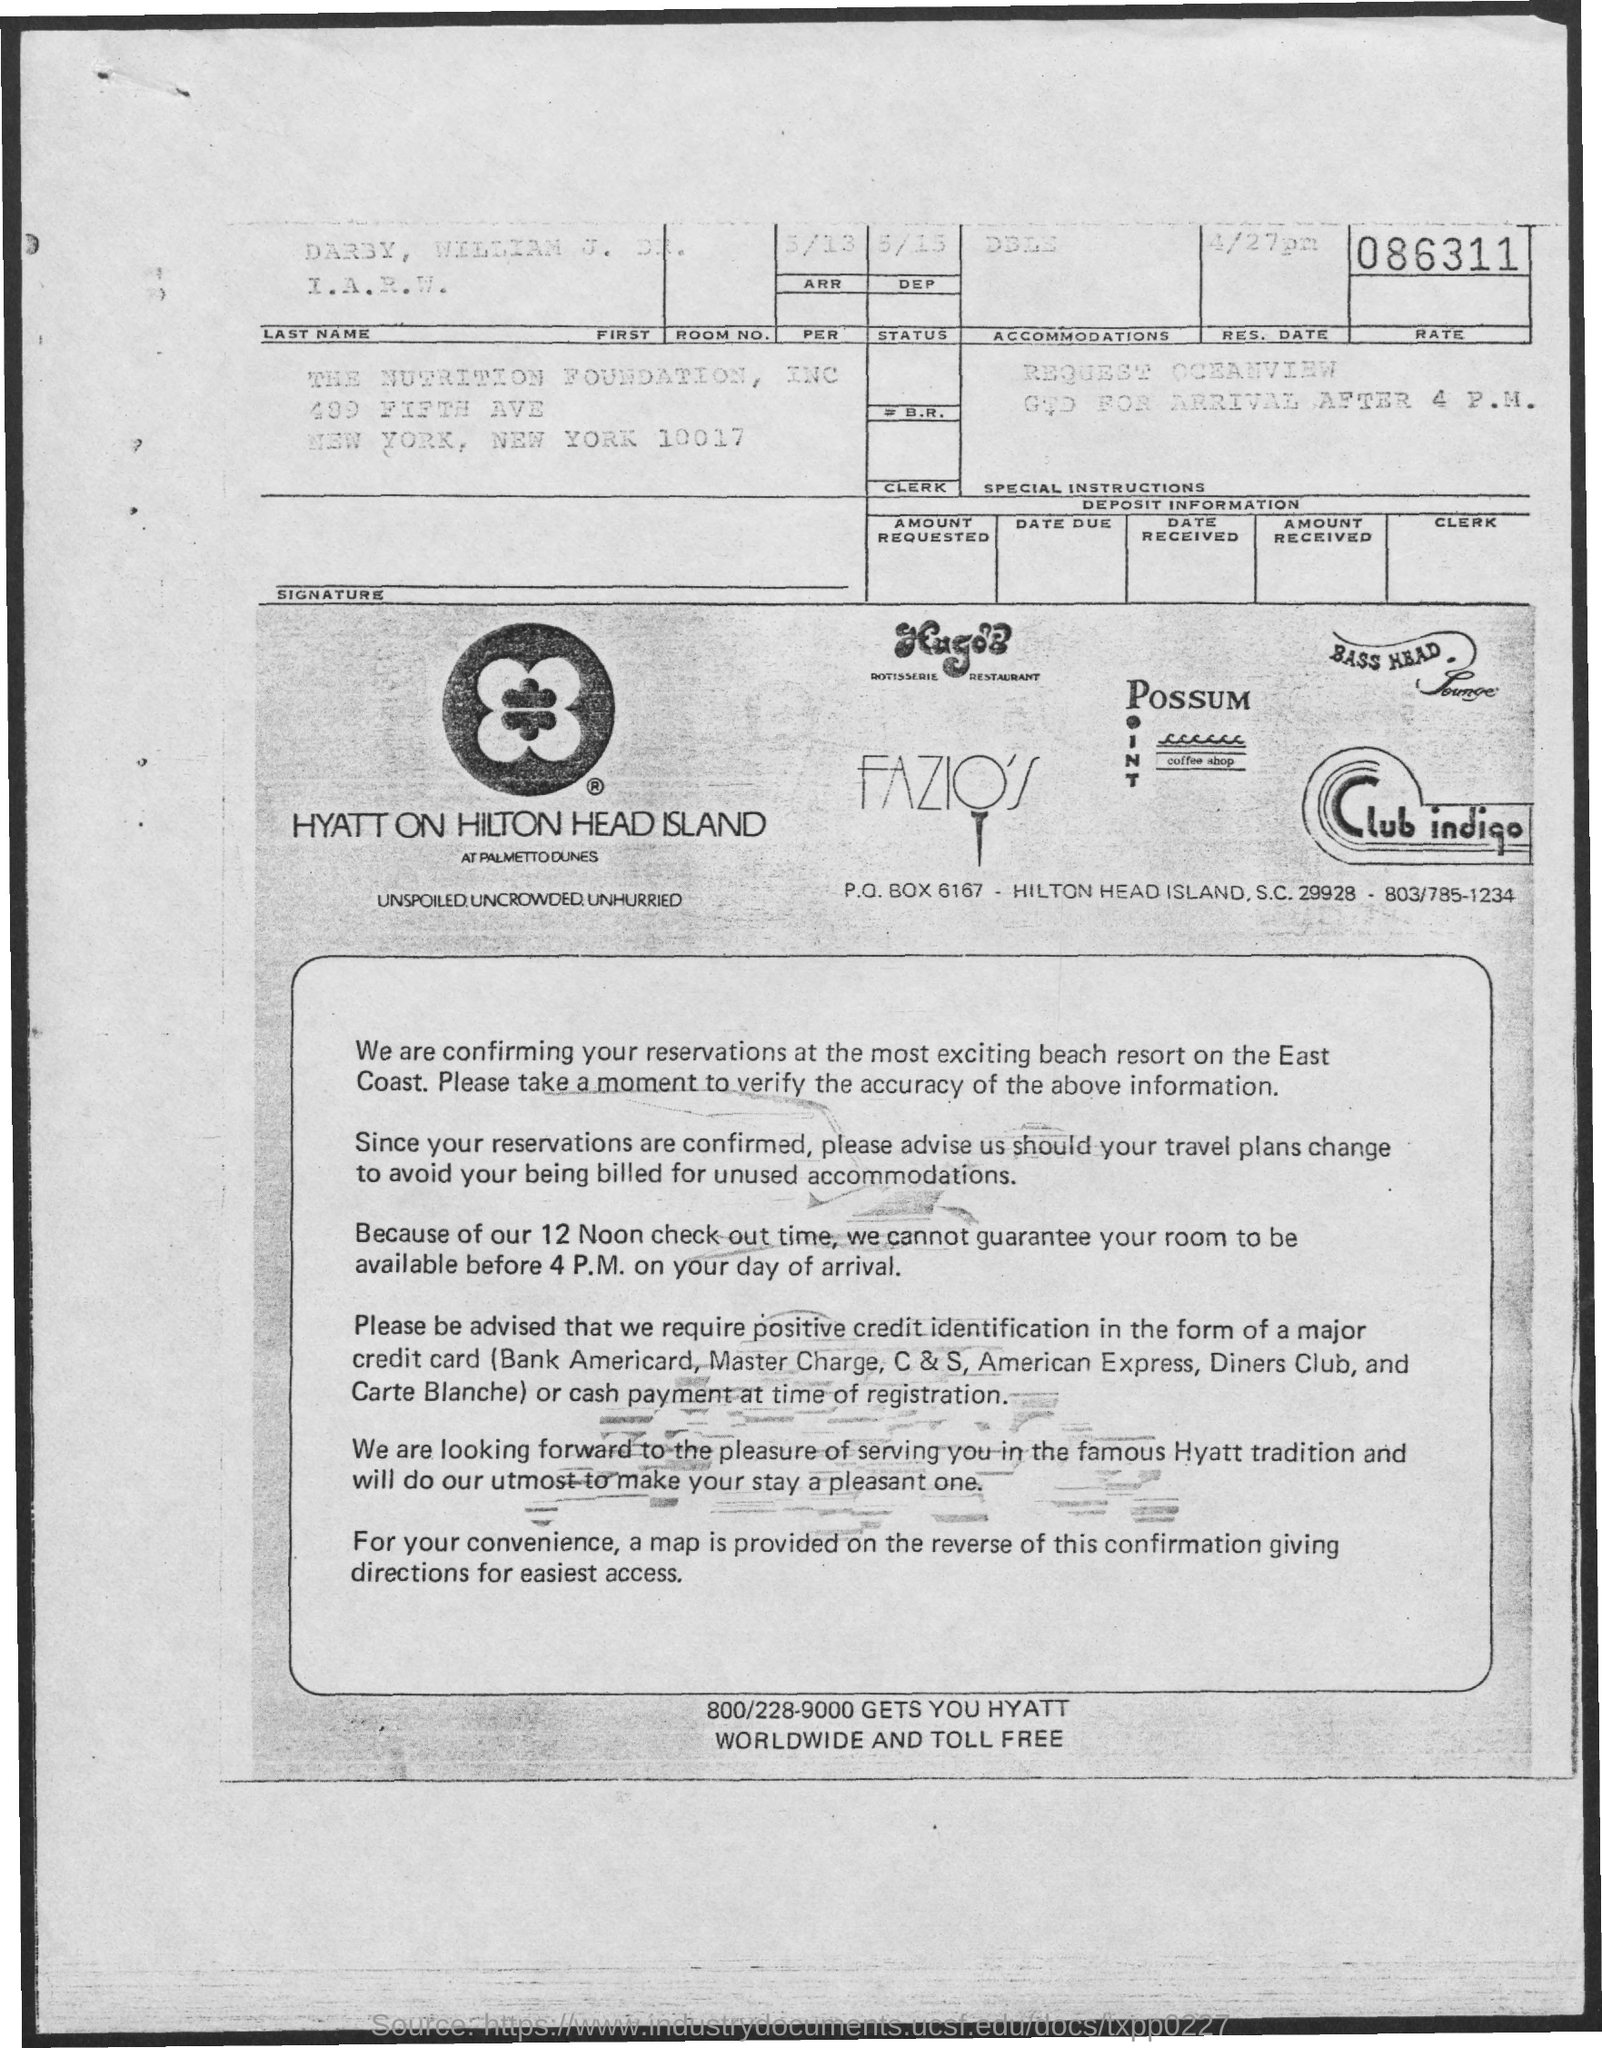Highlight a few significant elements in this photo. The checkout time is at 12 Noon. The reservation has been confirmed at a beach resort on the east coast. 